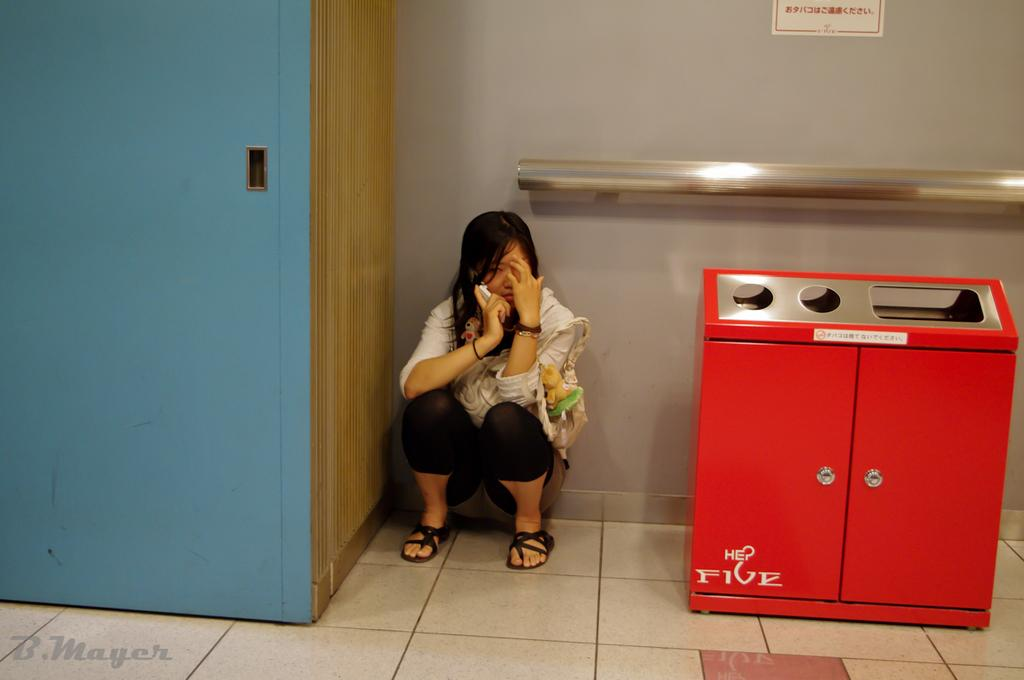<image>
Provide a brief description of the given image. A woman squats on the floor using her phone next to a trash can that reads 'HEP FIVE' 